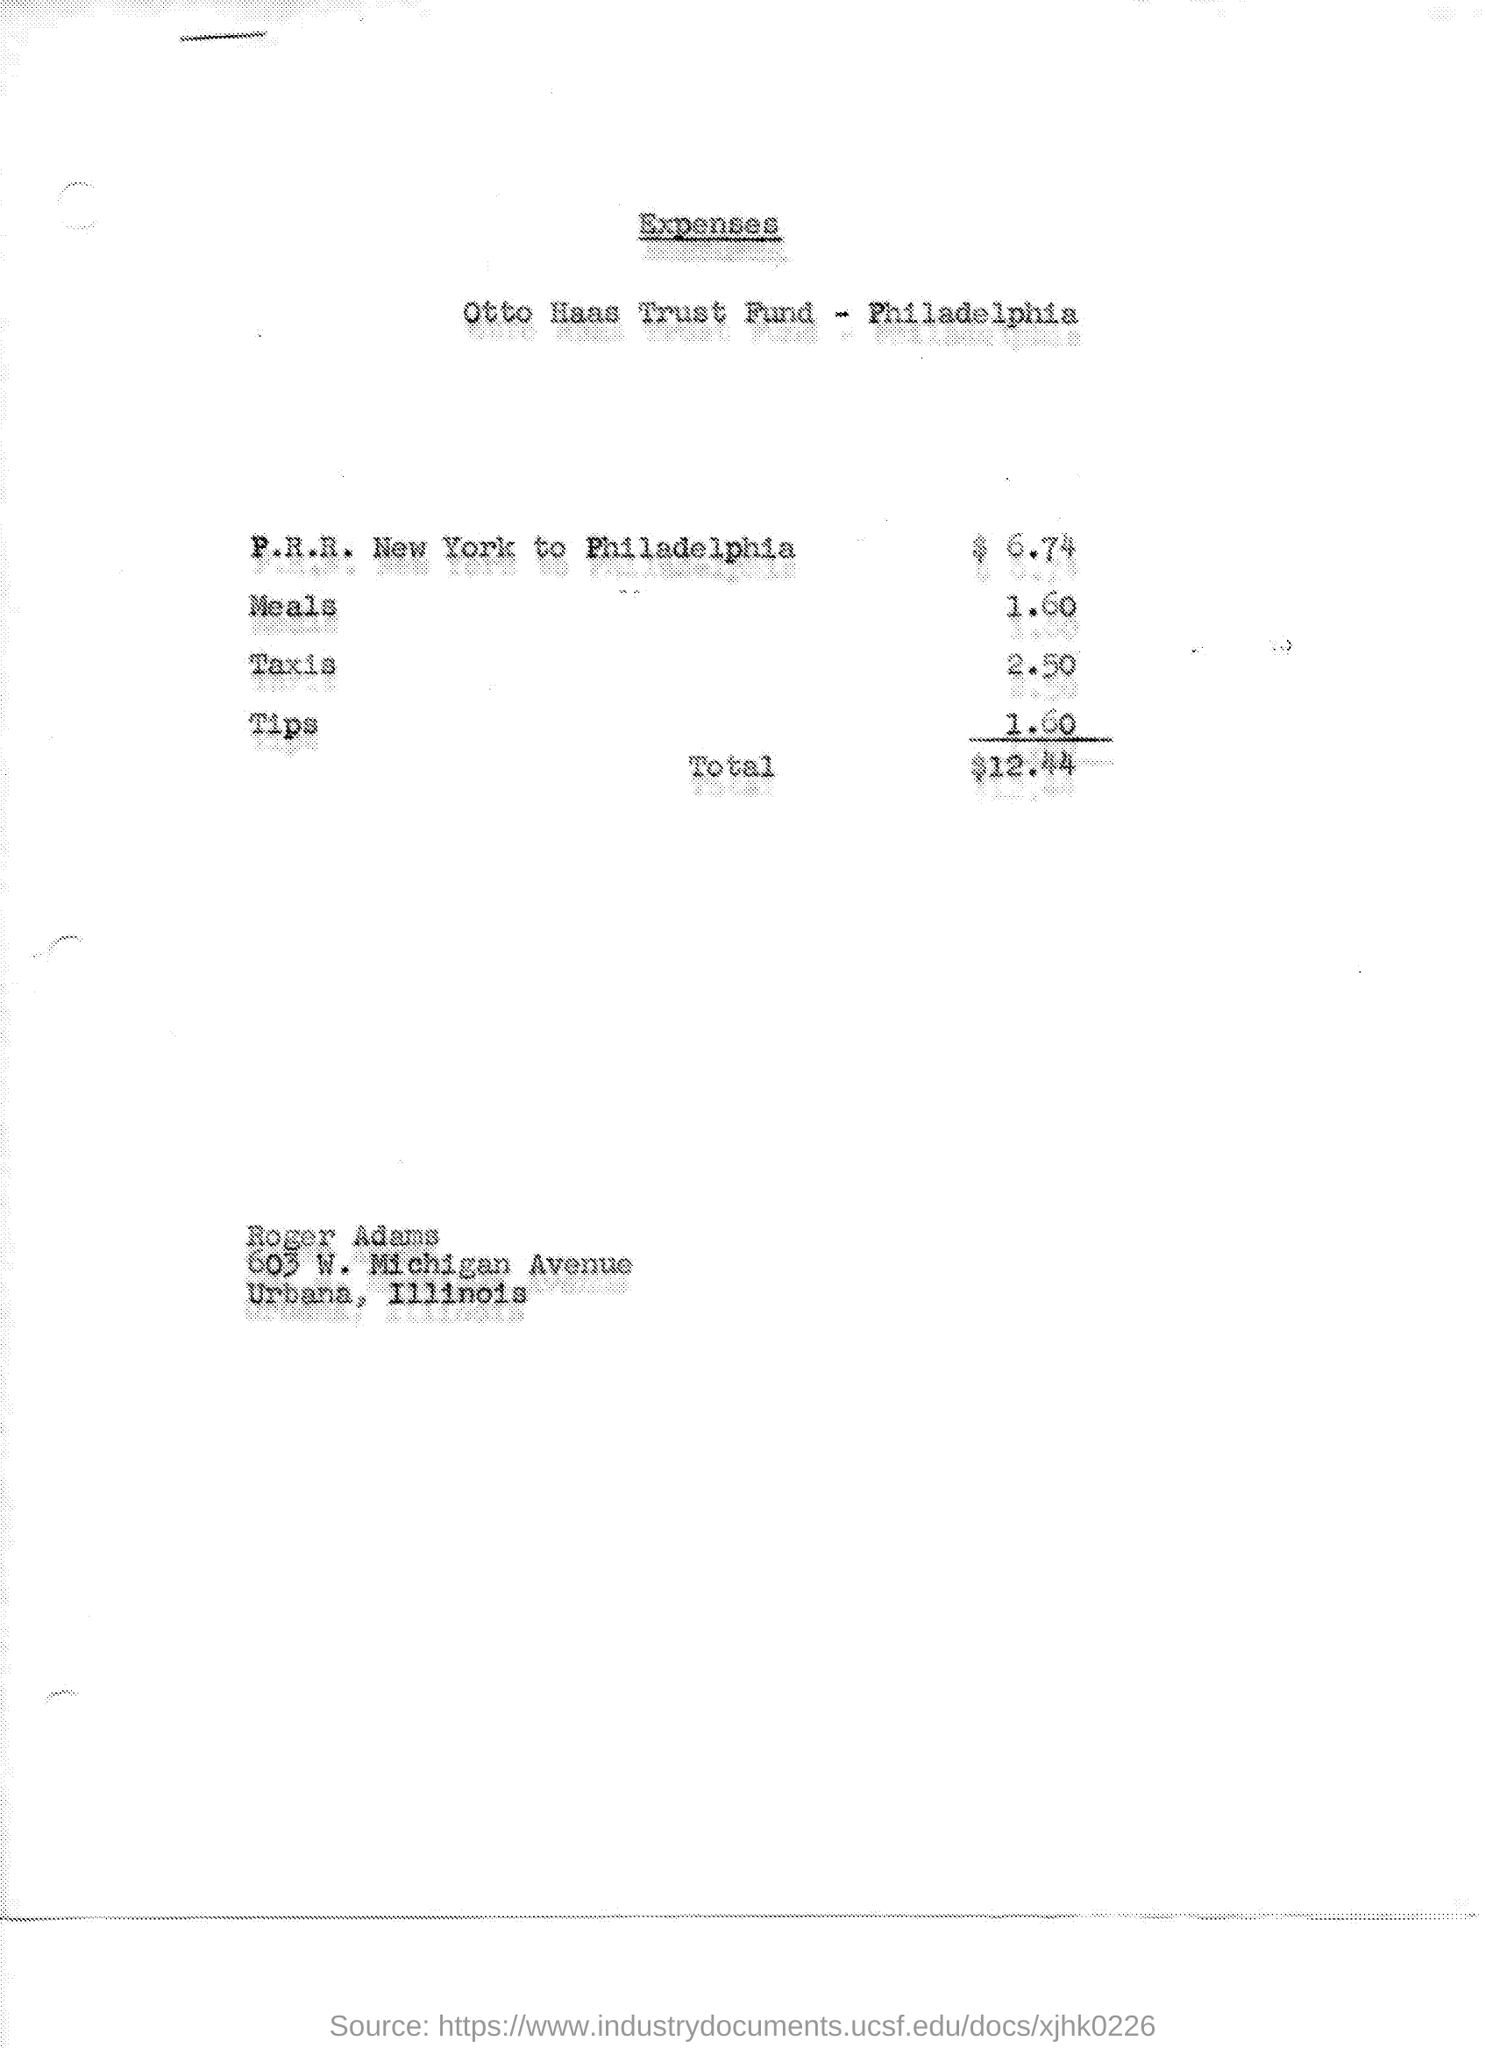How many dollars were spent for Taxis?
Your response must be concise. 2.50. What's amount  for P. R. R. New York to Philadelphia?
Keep it short and to the point. $6.74. Where did he used 1.60 dollars?
Offer a very short reply. Tips. 